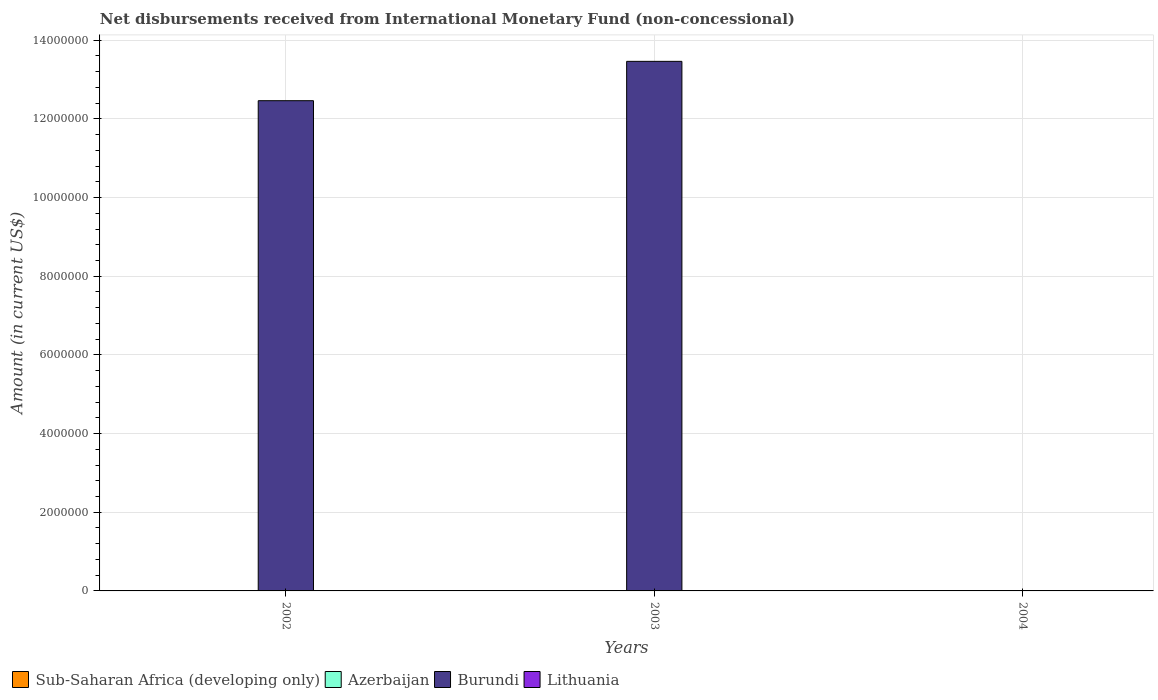How many different coloured bars are there?
Provide a succinct answer. 1. Are the number of bars per tick equal to the number of legend labels?
Provide a succinct answer. No. Are the number of bars on each tick of the X-axis equal?
Offer a very short reply. No. Across all years, what is the maximum amount of disbursements received from International Monetary Fund in Burundi?
Your answer should be compact. 1.35e+07. Across all years, what is the minimum amount of disbursements received from International Monetary Fund in Lithuania?
Provide a succinct answer. 0. What is the difference between the amount of disbursements received from International Monetary Fund in Burundi in 2002 and that in 2003?
Your answer should be compact. -1.00e+06. What is the difference between the amount of disbursements received from International Monetary Fund in Burundi in 2002 and the amount of disbursements received from International Monetary Fund in Lithuania in 2004?
Provide a short and direct response. 1.25e+07. What is the difference between the highest and the lowest amount of disbursements received from International Monetary Fund in Burundi?
Your response must be concise. 1.35e+07. In how many years, is the amount of disbursements received from International Monetary Fund in Sub-Saharan Africa (developing only) greater than the average amount of disbursements received from International Monetary Fund in Sub-Saharan Africa (developing only) taken over all years?
Your response must be concise. 0. Is the sum of the amount of disbursements received from International Monetary Fund in Burundi in 2002 and 2003 greater than the maximum amount of disbursements received from International Monetary Fund in Azerbaijan across all years?
Your answer should be very brief. Yes. How many bars are there?
Your response must be concise. 2. How many years are there in the graph?
Give a very brief answer. 3. Does the graph contain grids?
Offer a very short reply. Yes. Where does the legend appear in the graph?
Provide a succinct answer. Bottom left. How many legend labels are there?
Keep it short and to the point. 4. What is the title of the graph?
Offer a terse response. Net disbursements received from International Monetary Fund (non-concessional). What is the Amount (in current US$) of Azerbaijan in 2002?
Give a very brief answer. 0. What is the Amount (in current US$) of Burundi in 2002?
Provide a succinct answer. 1.25e+07. What is the Amount (in current US$) in Lithuania in 2002?
Provide a short and direct response. 0. What is the Amount (in current US$) in Sub-Saharan Africa (developing only) in 2003?
Offer a very short reply. 0. What is the Amount (in current US$) of Burundi in 2003?
Your answer should be compact. 1.35e+07. What is the Amount (in current US$) of Burundi in 2004?
Your answer should be very brief. 0. What is the Amount (in current US$) in Lithuania in 2004?
Provide a succinct answer. 0. Across all years, what is the maximum Amount (in current US$) in Burundi?
Your response must be concise. 1.35e+07. What is the total Amount (in current US$) in Burundi in the graph?
Your response must be concise. 2.59e+07. What is the difference between the Amount (in current US$) of Burundi in 2002 and that in 2003?
Give a very brief answer. -1.00e+06. What is the average Amount (in current US$) of Azerbaijan per year?
Your response must be concise. 0. What is the average Amount (in current US$) in Burundi per year?
Ensure brevity in your answer.  8.64e+06. What is the average Amount (in current US$) in Lithuania per year?
Ensure brevity in your answer.  0. What is the ratio of the Amount (in current US$) in Burundi in 2002 to that in 2003?
Keep it short and to the point. 0.93. What is the difference between the highest and the lowest Amount (in current US$) of Burundi?
Give a very brief answer. 1.35e+07. 